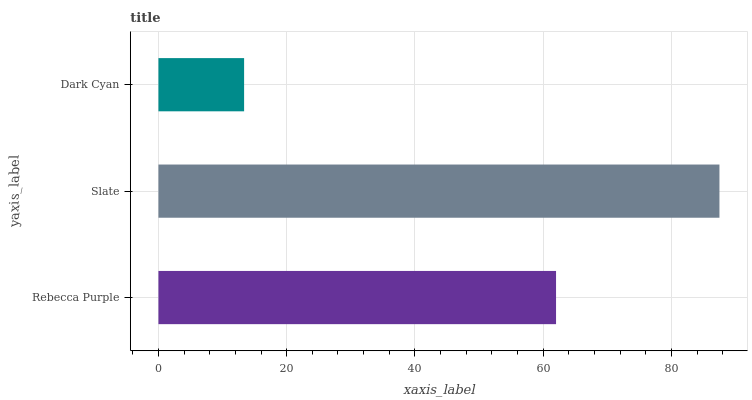Is Dark Cyan the minimum?
Answer yes or no. Yes. Is Slate the maximum?
Answer yes or no. Yes. Is Slate the minimum?
Answer yes or no. No. Is Dark Cyan the maximum?
Answer yes or no. No. Is Slate greater than Dark Cyan?
Answer yes or no. Yes. Is Dark Cyan less than Slate?
Answer yes or no. Yes. Is Dark Cyan greater than Slate?
Answer yes or no. No. Is Slate less than Dark Cyan?
Answer yes or no. No. Is Rebecca Purple the high median?
Answer yes or no. Yes. Is Rebecca Purple the low median?
Answer yes or no. Yes. Is Dark Cyan the high median?
Answer yes or no. No. Is Dark Cyan the low median?
Answer yes or no. No. 